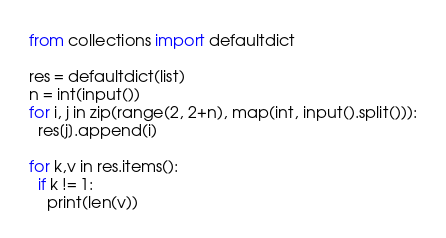Convert code to text. <code><loc_0><loc_0><loc_500><loc_500><_Python_>from collections import defaultdict

res = defaultdict(list)
n = int(input())
for i, j in zip(range(2, 2+n), map(int, input().split())):
  res[j].append(i)

for k,v in res.items():
  if k != 1:
  	print(len(v))</code> 